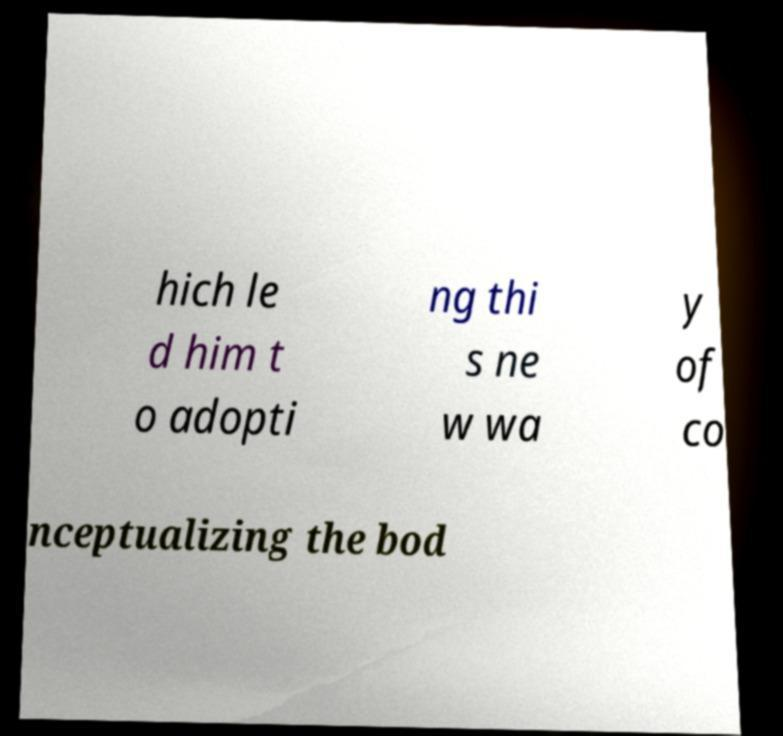For documentation purposes, I need the text within this image transcribed. Could you provide that? hich le d him t o adopti ng thi s ne w wa y of co nceptualizing the bod 